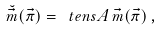<formula> <loc_0><loc_0><loc_500><loc_500>\breve { \vec { m } } ( \vec { \pi } ) = \ t e n s { A } \, \vec { m } ( \vec { \pi } ) \, ,</formula> 